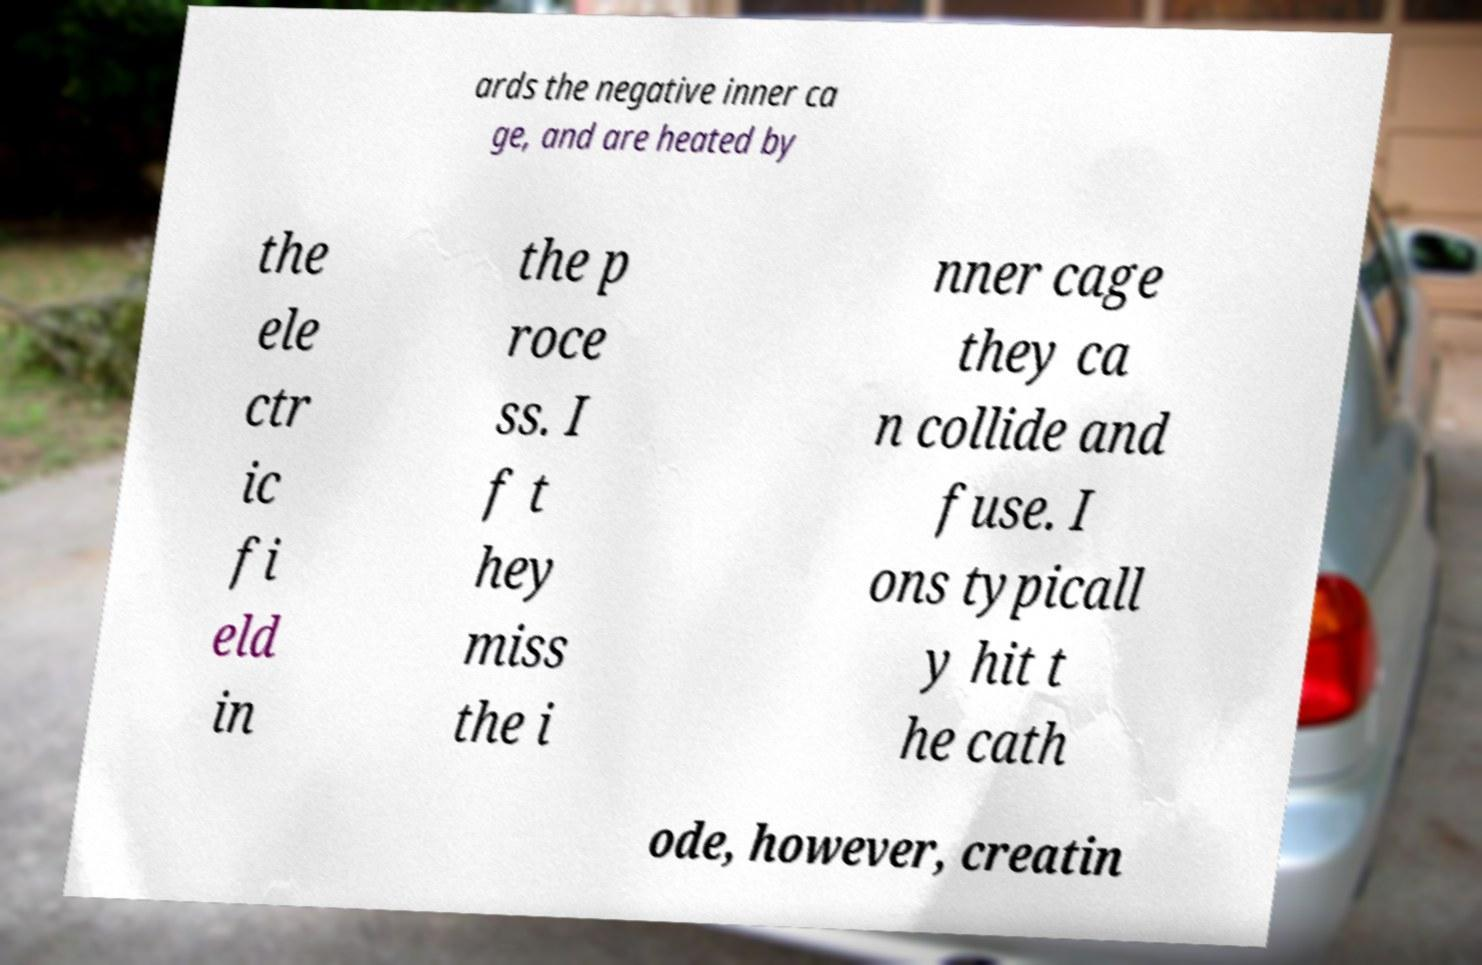I need the written content from this picture converted into text. Can you do that? ards the negative inner ca ge, and are heated by the ele ctr ic fi eld in the p roce ss. I f t hey miss the i nner cage they ca n collide and fuse. I ons typicall y hit t he cath ode, however, creatin 